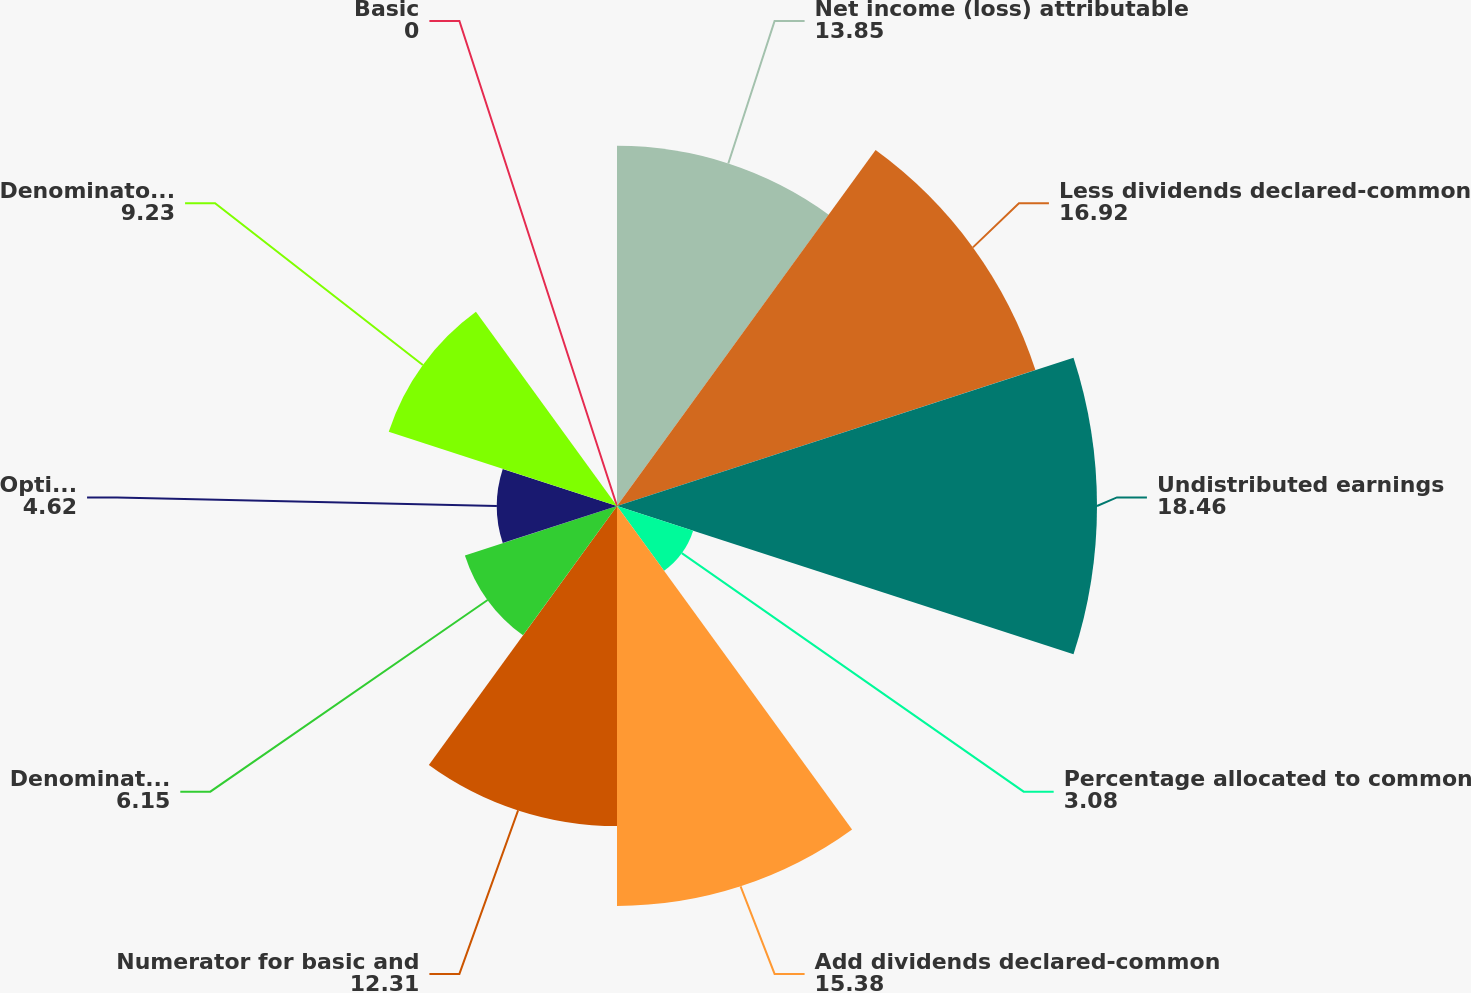Convert chart to OTSL. <chart><loc_0><loc_0><loc_500><loc_500><pie_chart><fcel>Net income (loss) attributable<fcel>Less dividends declared-common<fcel>Undistributed earnings<fcel>Percentage allocated to common<fcel>Add dividends declared-common<fcel>Numerator for basic and<fcel>Denominator for basic earnings<fcel>Options<fcel>Denominator for diluted<fcel>Basic<nl><fcel>13.85%<fcel>16.92%<fcel>18.46%<fcel>3.08%<fcel>15.38%<fcel>12.31%<fcel>6.15%<fcel>4.62%<fcel>9.23%<fcel>0.0%<nl></chart> 